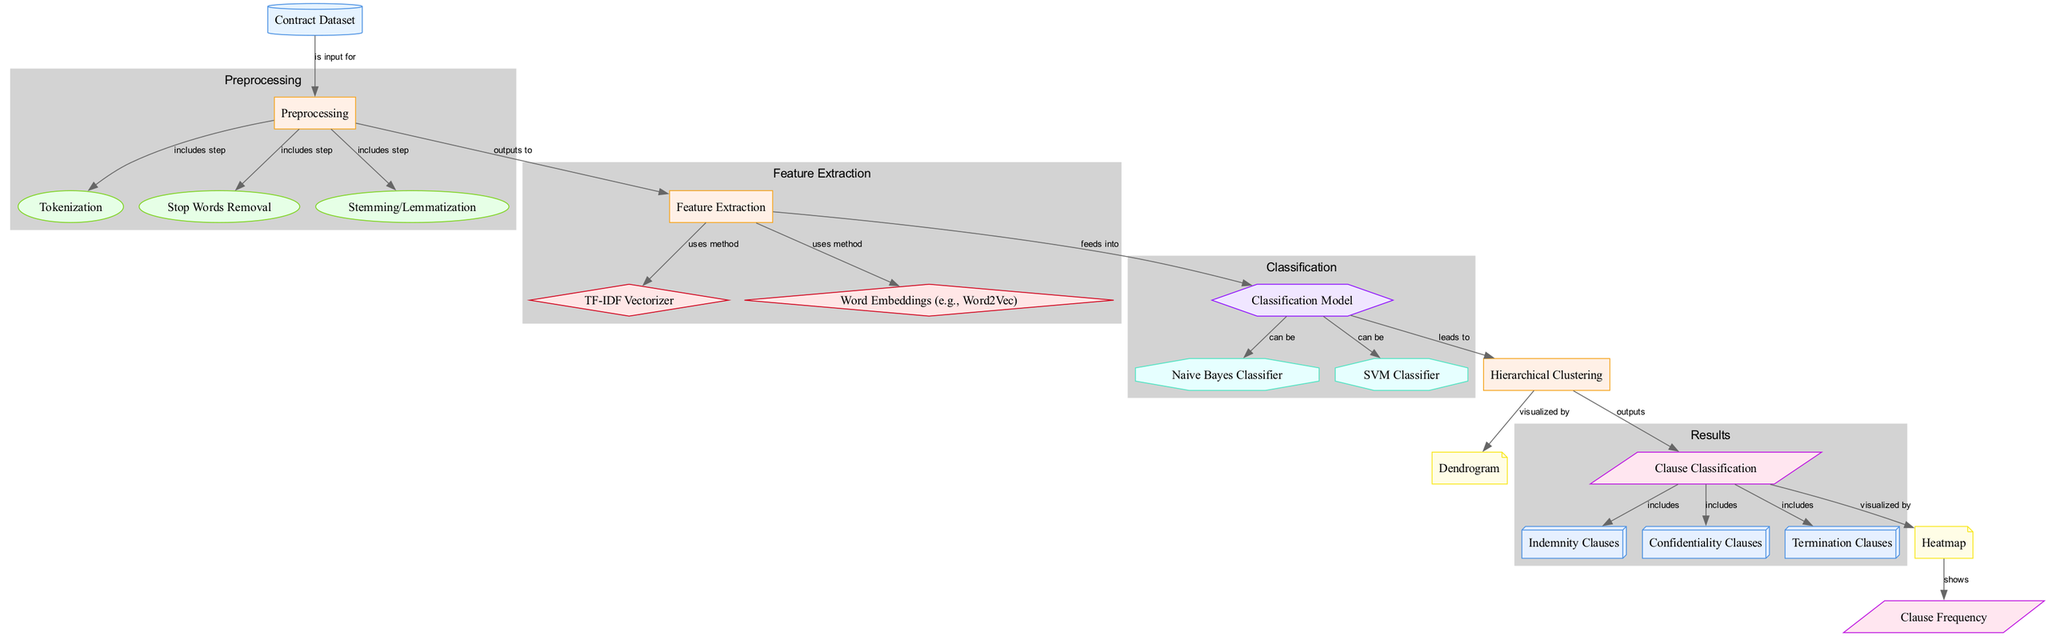What is the input for the process "Preprocessing"? The input for the process "Preprocessing" is the node labeled "Contract Dataset", which directly connects to "Preprocessing" in the diagram.
Answer: Contract Dataset How many types of classification algorithms are shown in this diagram? There are two types of classification algorithms depicted: Naive Bayes Classifier and SVM Classifier. Both are linked to the "Classification Model" node.
Answer: Two What types of clauses are included in the final classification output? The output includes three types of clauses: Indemnity Clauses, Confidentiality Clauses, and Termination Clauses. These are elements that fall under the "Clause Classification" node.
Answer: Indemnity Clauses, Confidentiality Clauses, Termination Clauses Which node visualizes the output of the hierarchical clustering process? The output of the hierarchical clustering process is visualized by the node labeled "Dendrogram", which is connected to the "Hierarchical Clustering" process node.
Answer: Dendrogram What process directly connects to the "Classification Model"? The "Feature Extraction" process directly connects to the "Classification Model," indicating it feeds the required information into the model for classification purposes.
Answer: Feature Extraction How does the "Heatmap" relate to the frequency of clauses? The "Heatmap" shows the frequency of various clause types as output from the classification process, illustrating the results of how often each clause is found in the dataset.
Answer: Shows How many steps are included in the "Preprocessing" process? The "Preprocessing" process includes three steps: Tokenization, Stop Words Removal, and Stemming/Lemmatization. Each of these is connected as a step within the preprocessing cluster.
Answer: Three What is the visual shape representation for the "Clause Frequency" node? The "Clause Frequency" node is visually represented as a parallelogram in the diagram, indicating it is a result derived from the classification process.
Answer: Parallelogram Which method is used for feature extraction in this diagram? There are two methods shown for feature extraction: TF-IDF Vectorizer and Word Embeddings (e.g., Word2Vec). Both are utilized in the process to extract relevant features from the contract dataset.
Answer: TF-IDF Vectorizer, Word Embeddings (e.g., Word2Vec) 